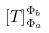Convert formula to latex. <formula><loc_0><loc_0><loc_500><loc_500>[ T ] _ { \Phi _ { a } } ^ { \Phi _ { b } }</formula> 